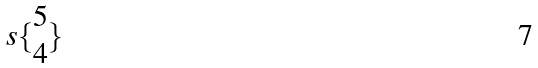Convert formula to latex. <formula><loc_0><loc_0><loc_500><loc_500>s \{ \begin{matrix} 5 \\ 4 \end{matrix} \}</formula> 